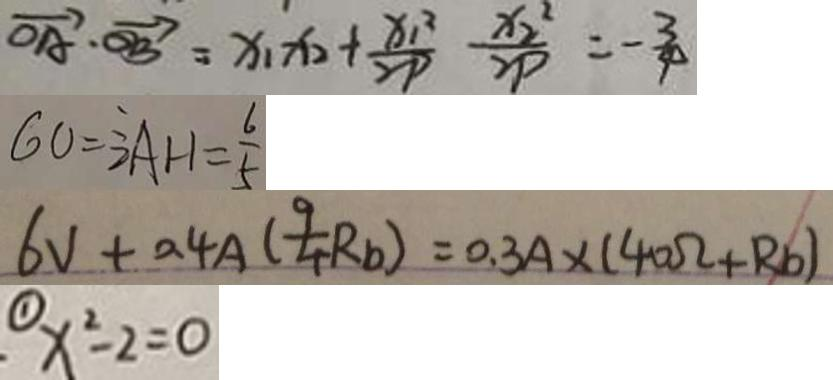<formula> <loc_0><loc_0><loc_500><loc_500>\overrightarrow { O A } \cdot \overrightarrow { O B } = x _ { 1 } x _ { 2 } + \frac { x _ { 1 } ^ { 2 } } { 2 P } \frac { x _ { 2 } ^ { 2 } } { 2 P } = - \frac { 3 } { 4 } 
 6 0 = 3 \frac { 1 } { 2 } A H = \frac { 6 } { 5 } 
 6 V + 0 . 4 A ( \frac { 9 } { 4 } R _ { b } ) = 0 . 3 A \times ( 4 0 \Omega + R _ { b } ) 
 \textcircled { 1 } x ^ { 2 } - 2 = 0</formula> 